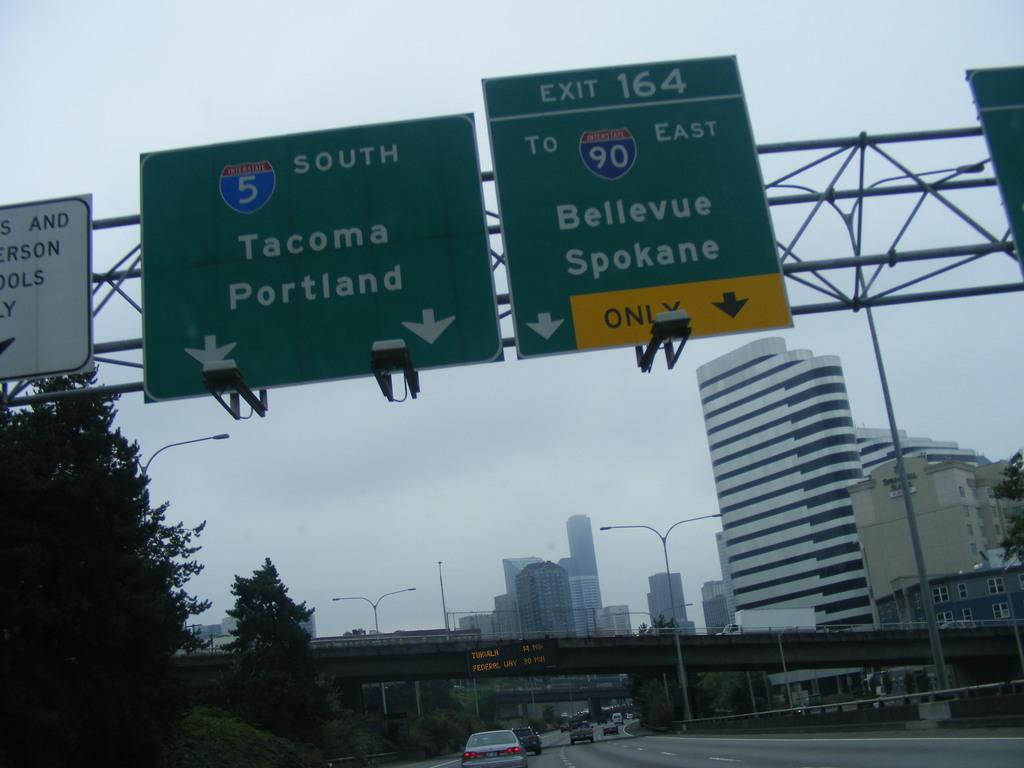Provide a one-sentence caption for the provided image. Highway signs point towards the cities of Portland, Tacoma, Bellevue and Spokane. 